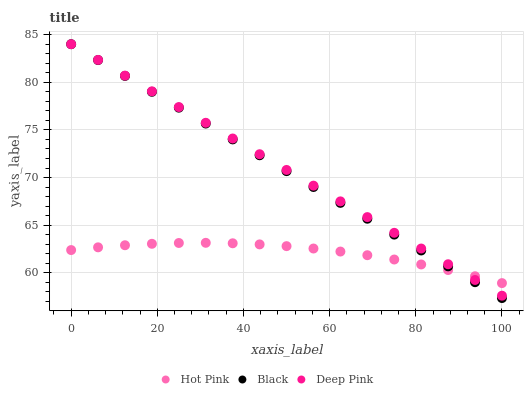Does Hot Pink have the minimum area under the curve?
Answer yes or no. Yes. Does Deep Pink have the maximum area under the curve?
Answer yes or no. Yes. Does Black have the minimum area under the curve?
Answer yes or no. No. Does Black have the maximum area under the curve?
Answer yes or no. No. Is Deep Pink the smoothest?
Answer yes or no. Yes. Is Hot Pink the roughest?
Answer yes or no. Yes. Is Black the smoothest?
Answer yes or no. No. Is Black the roughest?
Answer yes or no. No. Does Black have the lowest value?
Answer yes or no. Yes. Does Deep Pink have the lowest value?
Answer yes or no. No. Does Deep Pink have the highest value?
Answer yes or no. Yes. Does Black intersect Deep Pink?
Answer yes or no. Yes. Is Black less than Deep Pink?
Answer yes or no. No. Is Black greater than Deep Pink?
Answer yes or no. No. 